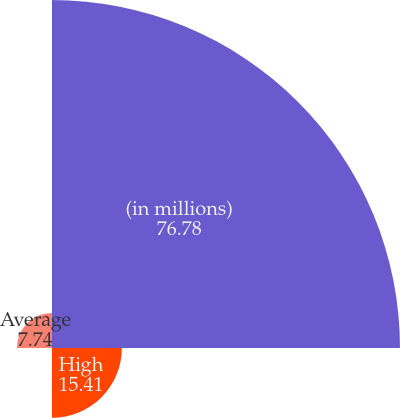Convert chart. <chart><loc_0><loc_0><loc_500><loc_500><pie_chart><fcel>(in millions)<fcel>High<fcel>Low<fcel>Average<nl><fcel>76.78%<fcel>15.41%<fcel>0.07%<fcel>7.74%<nl></chart> 